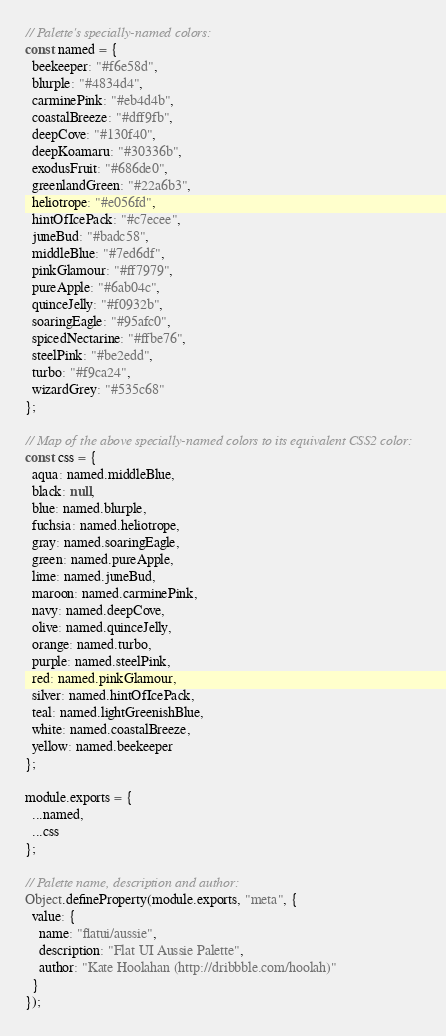Convert code to text. <code><loc_0><loc_0><loc_500><loc_500><_JavaScript_>// Palette's specially-named colors:
const named = {
  beekeeper: "#f6e58d",
  blurple: "#4834d4",
  carminePink: "#eb4d4b",
  coastalBreeze: "#dff9fb",
  deepCove: "#130f40",
  deepKoamaru: "#30336b",
  exodusFruit: "#686de0",
  greenlandGreen: "#22a6b3",
  heliotrope: "#e056fd",
  hintOfIcePack: "#c7ecee",
  juneBud: "#badc58",
  middleBlue: "#7ed6df",
  pinkGlamour: "#ff7979",
  pureApple: "#6ab04c",
  quinceJelly: "#f0932b",
  soaringEagle: "#95afc0",
  spicedNectarine: "#ffbe76",
  steelPink: "#be2edd",
  turbo: "#f9ca24",
  wizardGrey: "#535c68"
};

// Map of the above specially-named colors to its equivalent CSS2 color:
const css = {
  aqua: named.middleBlue,
  black: null,
  blue: named.blurple,
  fuchsia: named.heliotrope,
  gray: named.soaringEagle,
  green: named.pureApple,
  lime: named.juneBud,
  maroon: named.carminePink,
  navy: named.deepCove,
  olive: named.quinceJelly,
  orange: named.turbo,
  purple: named.steelPink,
  red: named.pinkGlamour,
  silver: named.hintOfIcePack,
  teal: named.lightGreenishBlue,
  white: named.coastalBreeze,
  yellow: named.beekeeper
};

module.exports = {
  ...named,
  ...css
};

// Palette name, description and author:
Object.defineProperty(module.exports, "meta", {
  value: {
    name: "flatui/aussie",
    description: "Flat UI Aussie Palette",
    author: "Kate Hoolahan (http://dribbble.com/hoolah)"
  }
});
</code> 